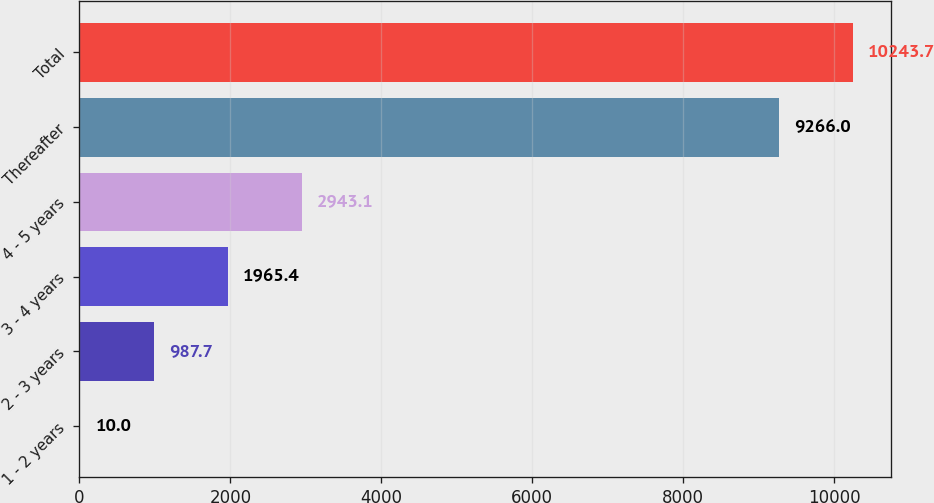Convert chart. <chart><loc_0><loc_0><loc_500><loc_500><bar_chart><fcel>1 - 2 years<fcel>2 - 3 years<fcel>3 - 4 years<fcel>4 - 5 years<fcel>Thereafter<fcel>Total<nl><fcel>10<fcel>987.7<fcel>1965.4<fcel>2943.1<fcel>9266<fcel>10243.7<nl></chart> 